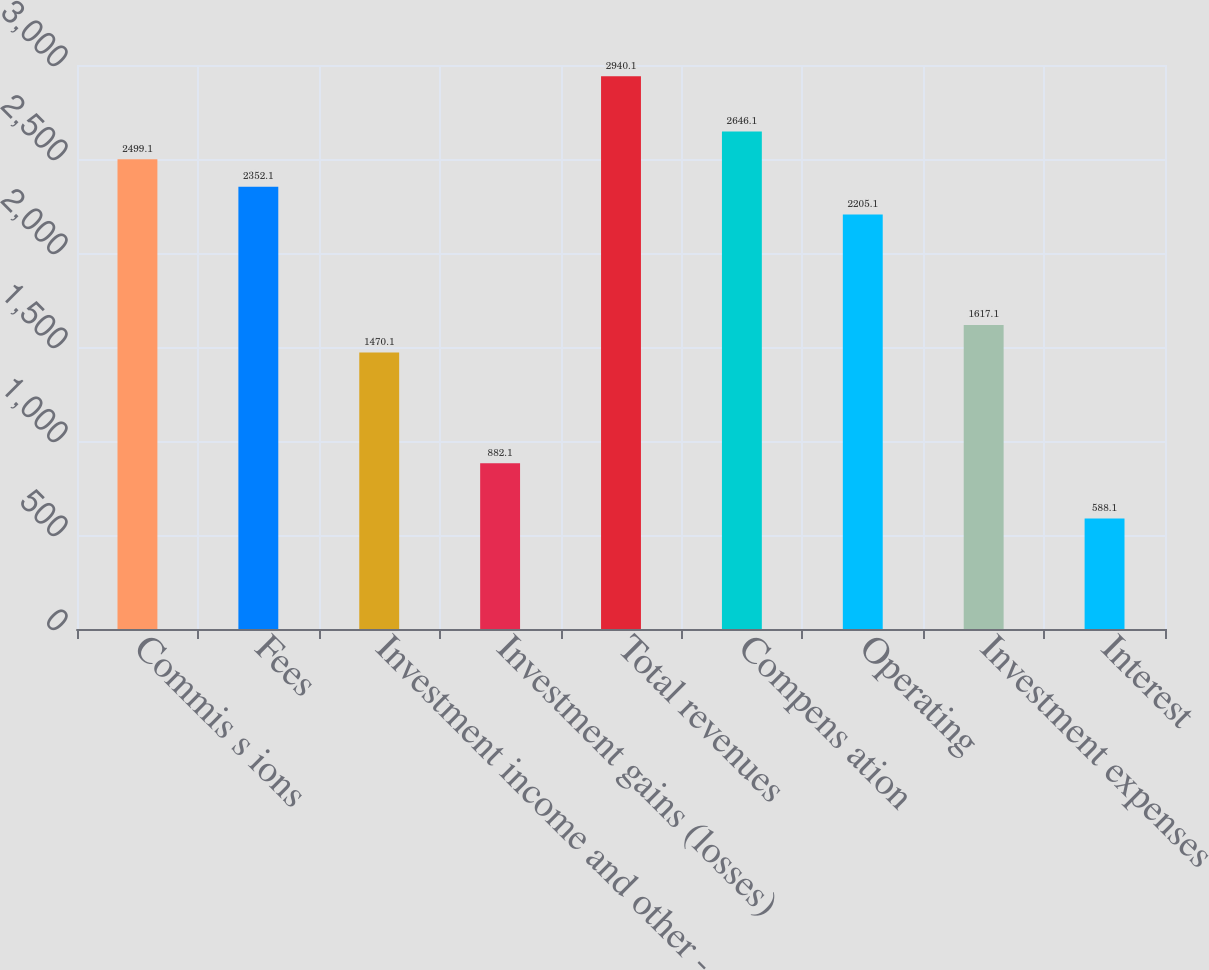Convert chart to OTSL. <chart><loc_0><loc_0><loc_500><loc_500><bar_chart><fcel>Commis s ions<fcel>Fees<fcel>Investment income and other -<fcel>Investment gains (losses)<fcel>Total revenues<fcel>Compens ation<fcel>Operating<fcel>Investment expenses<fcel>Interest<nl><fcel>2499.1<fcel>2352.1<fcel>1470.1<fcel>882.1<fcel>2940.1<fcel>2646.1<fcel>2205.1<fcel>1617.1<fcel>588.1<nl></chart> 